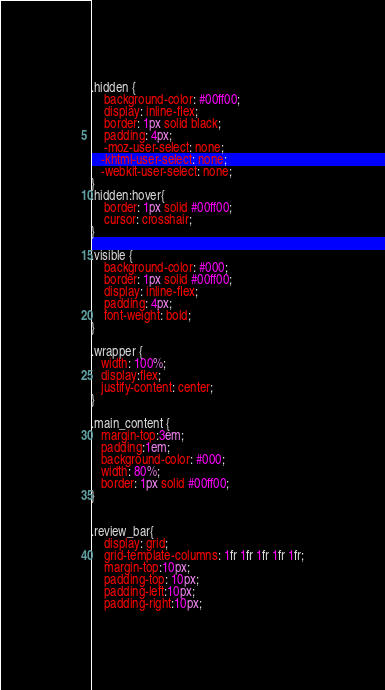<code> <loc_0><loc_0><loc_500><loc_500><_CSS_>.hidden {
    background-color: #00ff00;
    display: inline-flex;
    border: 1px solid black;
    padding: 4px;
    -moz-user-select: none;
   -khtml-user-select: none;
   -webkit-user-select: none;
}
.hidden:hover{
    border: 1px solid #00ff00;
    cursor: crosshair;
}

.visible {
    background-color: #000;
    border: 1px solid #00ff00;
    display: inline-flex;
    padding: 4px;
    font-weight: bold;
}

.wrapper {
   width: 100%;
   display:flex;
   justify-content: center;
}

.main_content {
   margin-top:3em;
   padding:1em;
   background-color: #000;
   width: 80%;
   border: 1px solid #00ff00;
}


.review_bar{
    display: grid;
    grid-template-columns: 1fr 1fr 1fr 1fr 1fr;
    margin-top:10px;
    padding-top: 10px;
    padding-left:10px;
    padding-right:10px;</code> 